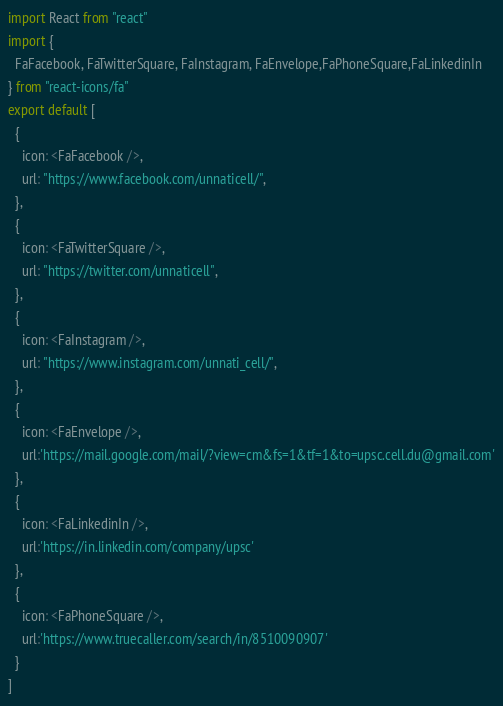<code> <loc_0><loc_0><loc_500><loc_500><_JavaScript_>import React from "react"
import {
  FaFacebook, FaTwitterSquare, FaInstagram, FaEnvelope,FaPhoneSquare,FaLinkedinIn
} from "react-icons/fa"
export default [
  {
    icon: <FaFacebook />,
    url: "https://www.facebook.com/unnaticell/",
  },
  {
    icon: <FaTwitterSquare />,
    url: "https://twitter.com/unnaticell",
  },
  {
    icon: <FaInstagram />,
    url: "https://www.instagram.com/unnati_cell/",
  },
  {
    icon: <FaEnvelope />,
    url:'https://mail.google.com/mail/?view=cm&fs=1&tf=1&to=upsc.cell.du@gmail.com'
  },
  {
    icon: <FaLinkedinIn />,
    url:'https://in.linkedin.com/company/upsc'
  },
  {
    icon: <FaPhoneSquare />,
    url:'https://www.truecaller.com/search/in/8510090907'
  }
]
</code> 